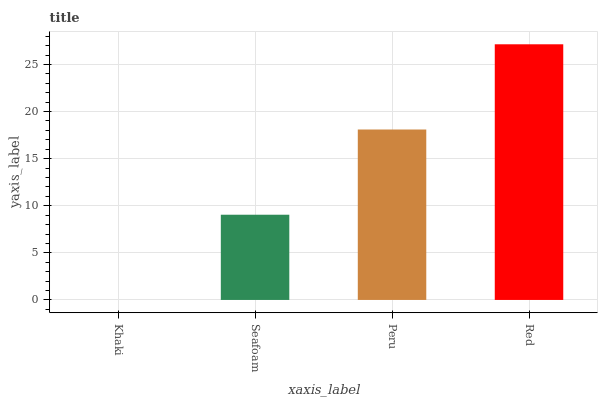Is Khaki the minimum?
Answer yes or no. Yes. Is Red the maximum?
Answer yes or no. Yes. Is Seafoam the minimum?
Answer yes or no. No. Is Seafoam the maximum?
Answer yes or no. No. Is Seafoam greater than Khaki?
Answer yes or no. Yes. Is Khaki less than Seafoam?
Answer yes or no. Yes. Is Khaki greater than Seafoam?
Answer yes or no. No. Is Seafoam less than Khaki?
Answer yes or no. No. Is Peru the high median?
Answer yes or no. Yes. Is Seafoam the low median?
Answer yes or no. Yes. Is Red the high median?
Answer yes or no. No. Is Red the low median?
Answer yes or no. No. 